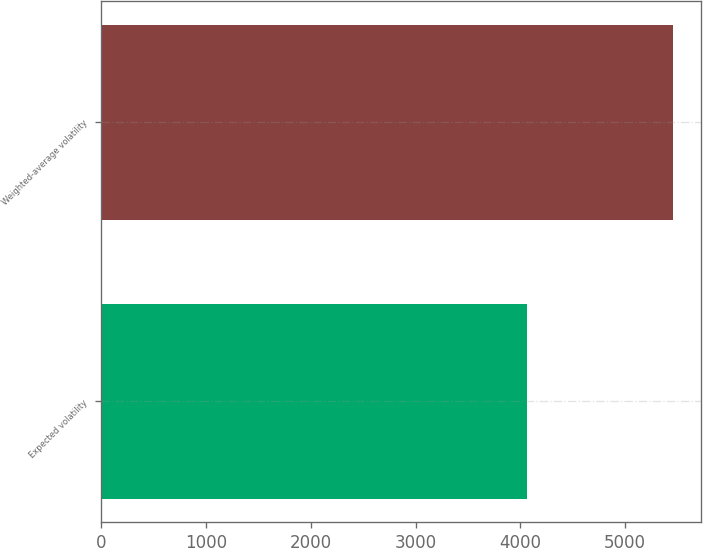<chart> <loc_0><loc_0><loc_500><loc_500><bar_chart><fcel>Expected volatility<fcel>Weighted-average volatility<nl><fcel>4060<fcel>5455<nl></chart> 